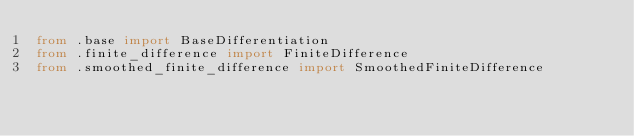<code> <loc_0><loc_0><loc_500><loc_500><_Python_>from .base import BaseDifferentiation
from .finite_difference import FiniteDifference
from .smoothed_finite_difference import SmoothedFiniteDifference
</code> 